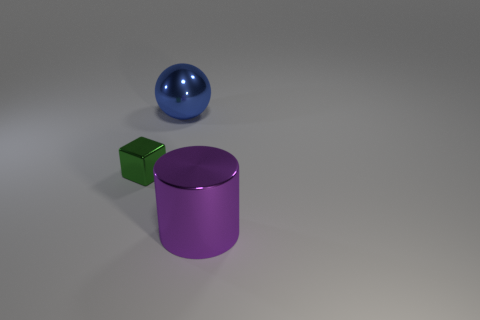Add 3 big gray cylinders. How many objects exist? 6 Subtract all spheres. How many objects are left? 2 Subtract all small yellow rubber balls. Subtract all big metallic objects. How many objects are left? 1 Add 2 spheres. How many spheres are left? 3 Add 3 rubber cubes. How many rubber cubes exist? 3 Subtract 0 red cylinders. How many objects are left? 3 Subtract 1 spheres. How many spheres are left? 0 Subtract all blue cubes. Subtract all cyan cylinders. How many cubes are left? 1 Subtract all green spheres. How many cyan cylinders are left? 0 